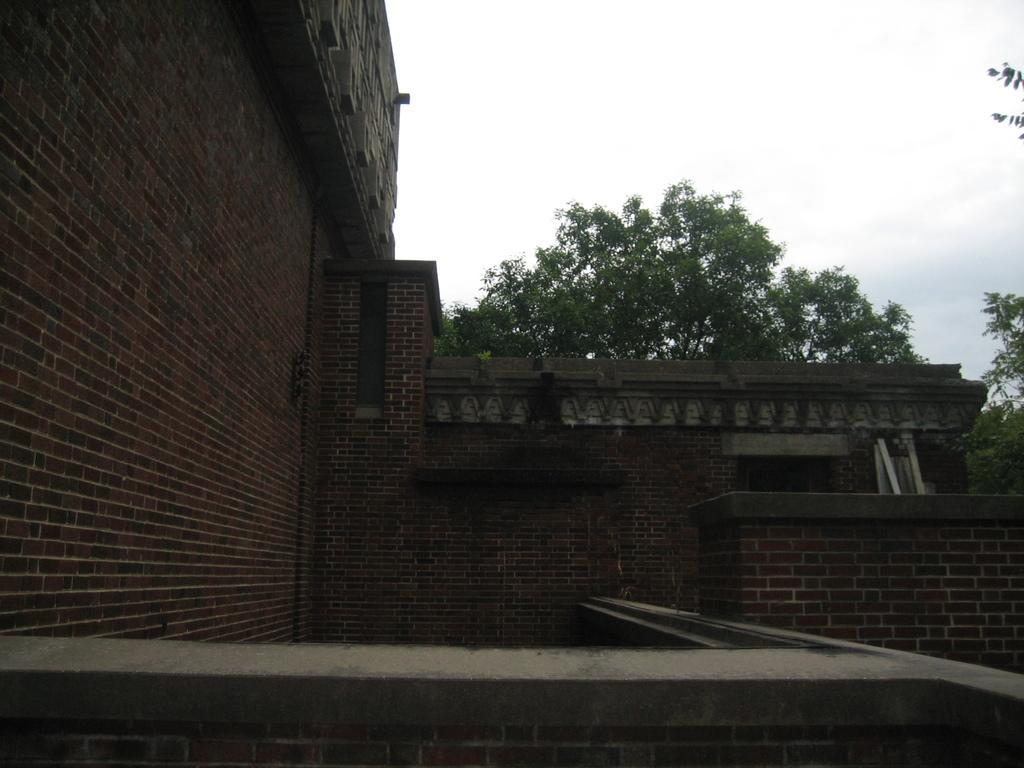Please provide a concise description of this image. In this picture we can see some buildings and trees. 